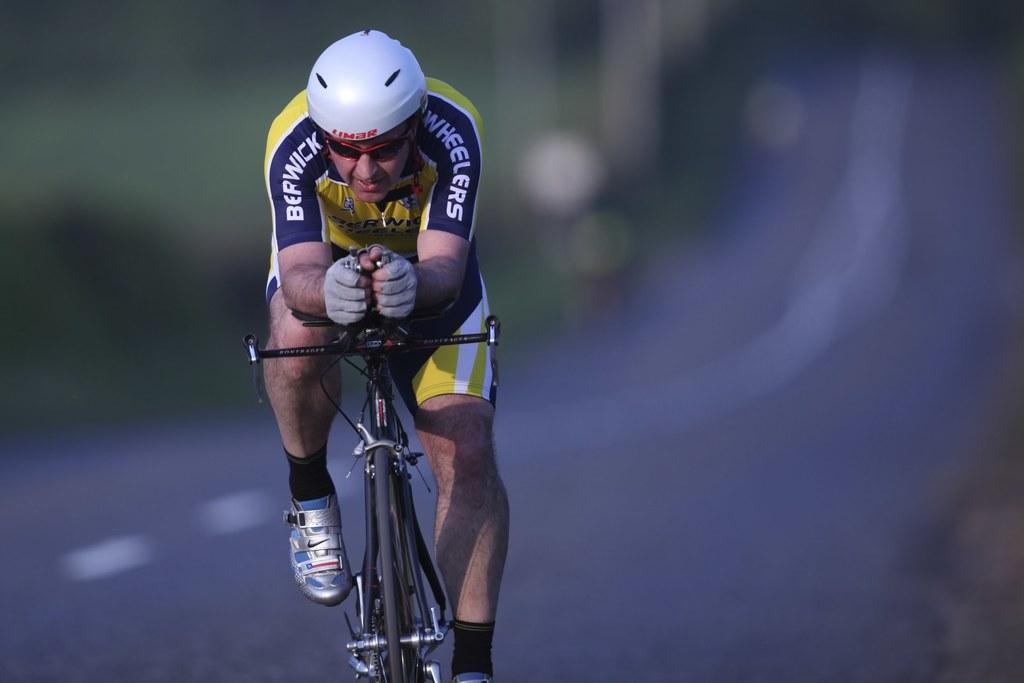What is the man in the image doing? The man is riding a bicycle in the image. Where is the man located in the image? The man is on the road in the image. What safety equipment is the man wearing? The man is wearing a helmet in the image. What accessory is the man wearing on his face? The man is wearing glasses in the image. How much money is the man holding in the image? There is no indication in the image that the man is holding money. 